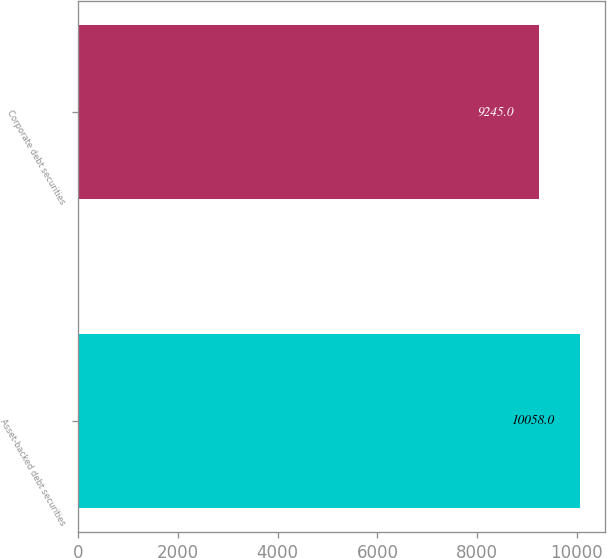Convert chart. <chart><loc_0><loc_0><loc_500><loc_500><bar_chart><fcel>Asset-backed debt securities<fcel>Corporate debt securities<nl><fcel>10058<fcel>9245<nl></chart> 